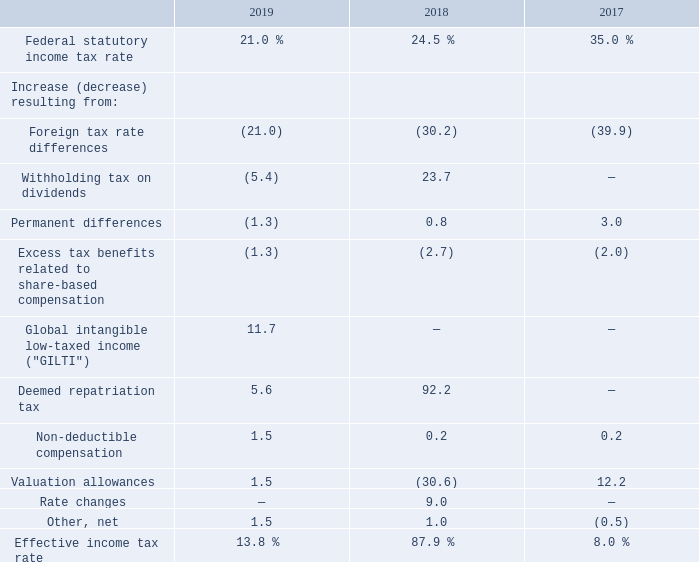The following is a reconciliation of the federal statutory income tax rate to the effective income tax rates reflected in the Consolidated Statements of Comprehensive Income for fiscal 2019, 2018 and 2017:
The effective tax rate for fiscal 2019 was lower than the effective tax rate for fiscal 2018 primarily due to the impact of the U.S. Tax Cuts and Jobs Act (“Tax Reform”) that was recorded in fiscal 2018. During fiscal 2019, the Company reasserted that certain historical undistributed earnings of two foreign subsidiaries will be permanently reinvested which provided a $10.5 million benefit to the effective tax rate. The impact of the changes in the Company's assertion has been included in "Withholding tax on dividends" in the effective income tax reconciliation above. The reduction to the effective tax rate compared to fiscal 2018 was offset by an increase due to the GILTI provisions of Tax Reform in fiscal 2019. The GILTI impact in the table above includes the deduction allowed by the regulations as well as the foreign tax credits attributed to GILTI. The Company has elected to treat the income tax effects of GILTI as a period cost. The effective tax rate for fiscal 2018 was higher than the effective tax rate for fiscal 2017 primarily due to expenses related to Tax Reform.
During fiscal 2019, the Company recorded a $1.9 million increase to its valuation allowance due to continuing losses in certain jurisdictions within the AMER and EMEA segments, partially offset by an expiration of net operating losses that had a valuation allowance recorded.
During fiscal 2018, the Company recorded a $32.9 million reduction to its valuation allowance which includes $9.7 million related to the U.S. federal tax rate change as part of Tax Reform from 35% to 21%, $21.0 million of carryforward credits and net operating losses utilized against the deemed repatriation of undistributed foreign earnings and $3.6 million for the release of the U.S. valuation allowance due to the expected future U.S. taxable income related to the GILTI provisions of Tax Reform. These benefits were partially offset by a $1.4 million increase in foreign valuation allowances in the EMEA segment.
During fiscal 2017, the Company recorded a $14.9 million addition to its valuation allowance relating to continuing losses in certain jurisdictions within the AMER and EMEA segments.
What was the company's addition to its valuation allowance during Fiscal 2017?
Answer scale should be: million. 14.9. What was the foreign tax rate differences in 2017?
Answer scale should be: percent. (39.9). What was the Federal statutory income tax rate in 2019?
Answer scale should be: percent. 21.0. How many years did the Federal statutory income tax rate exceed 30.0%? 2017
Answer: 1. Which years did the increase resulting from Non-deductible compensation exceed 1%? (2019:1.5)
Answer: 2019. What was the change in the increase resulting from permanent differences between 2017 and 2018?
Answer scale should be: percent. 0.8-3.0
Answer: -2.2. 